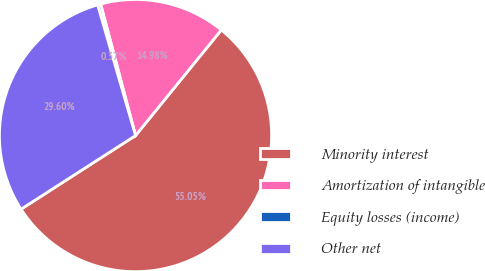Convert chart. <chart><loc_0><loc_0><loc_500><loc_500><pie_chart><fcel>Minority interest<fcel>Amortization of intangible<fcel>Equity losses (income)<fcel>Other net<nl><fcel>55.05%<fcel>14.98%<fcel>0.37%<fcel>29.6%<nl></chart> 